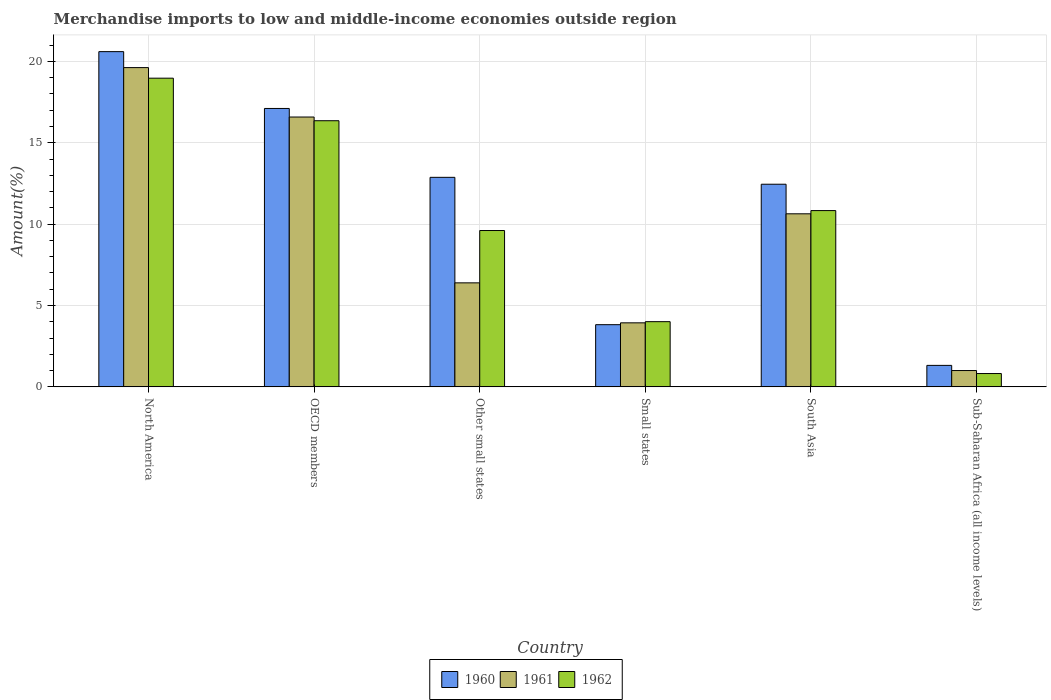How many different coloured bars are there?
Your answer should be very brief. 3. How many groups of bars are there?
Provide a short and direct response. 6. Are the number of bars on each tick of the X-axis equal?
Make the answer very short. Yes. How many bars are there on the 3rd tick from the left?
Make the answer very short. 3. How many bars are there on the 1st tick from the right?
Keep it short and to the point. 3. What is the label of the 3rd group of bars from the left?
Give a very brief answer. Other small states. What is the percentage of amount earned from merchandise imports in 1960 in OECD members?
Provide a succinct answer. 17.11. Across all countries, what is the maximum percentage of amount earned from merchandise imports in 1962?
Give a very brief answer. 18.97. Across all countries, what is the minimum percentage of amount earned from merchandise imports in 1962?
Make the answer very short. 0.82. In which country was the percentage of amount earned from merchandise imports in 1961 maximum?
Keep it short and to the point. North America. In which country was the percentage of amount earned from merchandise imports in 1961 minimum?
Offer a very short reply. Sub-Saharan Africa (all income levels). What is the total percentage of amount earned from merchandise imports in 1962 in the graph?
Make the answer very short. 60.58. What is the difference between the percentage of amount earned from merchandise imports in 1960 in North America and that in OECD members?
Provide a short and direct response. 3.49. What is the difference between the percentage of amount earned from merchandise imports in 1960 in North America and the percentage of amount earned from merchandise imports in 1962 in South Asia?
Provide a succinct answer. 9.77. What is the average percentage of amount earned from merchandise imports in 1962 per country?
Your answer should be compact. 10.1. What is the difference between the percentage of amount earned from merchandise imports of/in 1962 and percentage of amount earned from merchandise imports of/in 1960 in Sub-Saharan Africa (all income levels)?
Ensure brevity in your answer.  -0.5. In how many countries, is the percentage of amount earned from merchandise imports in 1962 greater than 12 %?
Provide a short and direct response. 2. What is the ratio of the percentage of amount earned from merchandise imports in 1961 in North America to that in Sub-Saharan Africa (all income levels)?
Provide a succinct answer. 19.54. Is the percentage of amount earned from merchandise imports in 1962 in Other small states less than that in Sub-Saharan Africa (all income levels)?
Ensure brevity in your answer.  No. What is the difference between the highest and the second highest percentage of amount earned from merchandise imports in 1962?
Your answer should be compact. -2.61. What is the difference between the highest and the lowest percentage of amount earned from merchandise imports in 1960?
Provide a short and direct response. 19.28. What does the 2nd bar from the left in Other small states represents?
Offer a very short reply. 1961. How many bars are there?
Offer a very short reply. 18. How many countries are there in the graph?
Your answer should be compact. 6. What is the difference between two consecutive major ticks on the Y-axis?
Provide a succinct answer. 5. Are the values on the major ticks of Y-axis written in scientific E-notation?
Give a very brief answer. No. Does the graph contain any zero values?
Offer a very short reply. No. Does the graph contain grids?
Your response must be concise. Yes. What is the title of the graph?
Give a very brief answer. Merchandise imports to low and middle-income economies outside region. Does "1983" appear as one of the legend labels in the graph?
Provide a short and direct response. No. What is the label or title of the Y-axis?
Keep it short and to the point. Amount(%). What is the Amount(%) of 1960 in North America?
Give a very brief answer. 20.6. What is the Amount(%) in 1961 in North America?
Offer a terse response. 19.62. What is the Amount(%) in 1962 in North America?
Ensure brevity in your answer.  18.97. What is the Amount(%) of 1960 in OECD members?
Your response must be concise. 17.11. What is the Amount(%) of 1961 in OECD members?
Your answer should be compact. 16.58. What is the Amount(%) in 1962 in OECD members?
Your answer should be compact. 16.35. What is the Amount(%) of 1960 in Other small states?
Keep it short and to the point. 12.87. What is the Amount(%) in 1961 in Other small states?
Provide a succinct answer. 6.39. What is the Amount(%) in 1962 in Other small states?
Provide a short and direct response. 9.61. What is the Amount(%) in 1960 in Small states?
Your response must be concise. 3.82. What is the Amount(%) in 1961 in Small states?
Provide a succinct answer. 3.93. What is the Amount(%) of 1962 in Small states?
Ensure brevity in your answer.  4.01. What is the Amount(%) in 1960 in South Asia?
Keep it short and to the point. 12.45. What is the Amount(%) of 1961 in South Asia?
Provide a succinct answer. 10.63. What is the Amount(%) of 1962 in South Asia?
Provide a succinct answer. 10.83. What is the Amount(%) of 1960 in Sub-Saharan Africa (all income levels)?
Your answer should be very brief. 1.32. What is the Amount(%) of 1961 in Sub-Saharan Africa (all income levels)?
Give a very brief answer. 1. What is the Amount(%) of 1962 in Sub-Saharan Africa (all income levels)?
Ensure brevity in your answer.  0.82. Across all countries, what is the maximum Amount(%) of 1960?
Ensure brevity in your answer.  20.6. Across all countries, what is the maximum Amount(%) in 1961?
Provide a short and direct response. 19.62. Across all countries, what is the maximum Amount(%) in 1962?
Your answer should be very brief. 18.97. Across all countries, what is the minimum Amount(%) of 1960?
Ensure brevity in your answer.  1.32. Across all countries, what is the minimum Amount(%) of 1961?
Make the answer very short. 1. Across all countries, what is the minimum Amount(%) of 1962?
Keep it short and to the point. 0.82. What is the total Amount(%) of 1960 in the graph?
Give a very brief answer. 68.17. What is the total Amount(%) in 1961 in the graph?
Provide a short and direct response. 58.16. What is the total Amount(%) of 1962 in the graph?
Your answer should be very brief. 60.58. What is the difference between the Amount(%) of 1960 in North America and that in OECD members?
Provide a short and direct response. 3.49. What is the difference between the Amount(%) of 1961 in North America and that in OECD members?
Make the answer very short. 3.04. What is the difference between the Amount(%) of 1962 in North America and that in OECD members?
Give a very brief answer. 2.61. What is the difference between the Amount(%) in 1960 in North America and that in Other small states?
Give a very brief answer. 7.72. What is the difference between the Amount(%) in 1961 in North America and that in Other small states?
Ensure brevity in your answer.  13.22. What is the difference between the Amount(%) in 1962 in North America and that in Other small states?
Ensure brevity in your answer.  9.36. What is the difference between the Amount(%) of 1960 in North America and that in Small states?
Your answer should be compact. 16.78. What is the difference between the Amount(%) of 1961 in North America and that in Small states?
Offer a terse response. 15.68. What is the difference between the Amount(%) in 1962 in North America and that in Small states?
Ensure brevity in your answer.  14.96. What is the difference between the Amount(%) of 1960 in North America and that in South Asia?
Ensure brevity in your answer.  8.15. What is the difference between the Amount(%) in 1961 in North America and that in South Asia?
Provide a succinct answer. 8.98. What is the difference between the Amount(%) in 1962 in North America and that in South Asia?
Your response must be concise. 8.13. What is the difference between the Amount(%) of 1960 in North America and that in Sub-Saharan Africa (all income levels)?
Keep it short and to the point. 19.28. What is the difference between the Amount(%) in 1961 in North America and that in Sub-Saharan Africa (all income levels)?
Provide a short and direct response. 18.61. What is the difference between the Amount(%) of 1962 in North America and that in Sub-Saharan Africa (all income levels)?
Provide a short and direct response. 18.15. What is the difference between the Amount(%) of 1960 in OECD members and that in Other small states?
Your answer should be very brief. 4.23. What is the difference between the Amount(%) of 1961 in OECD members and that in Other small states?
Give a very brief answer. 10.19. What is the difference between the Amount(%) of 1962 in OECD members and that in Other small states?
Provide a short and direct response. 6.75. What is the difference between the Amount(%) of 1960 in OECD members and that in Small states?
Ensure brevity in your answer.  13.28. What is the difference between the Amount(%) in 1961 in OECD members and that in Small states?
Offer a very short reply. 12.65. What is the difference between the Amount(%) of 1962 in OECD members and that in Small states?
Your answer should be compact. 12.35. What is the difference between the Amount(%) of 1960 in OECD members and that in South Asia?
Keep it short and to the point. 4.66. What is the difference between the Amount(%) in 1961 in OECD members and that in South Asia?
Offer a very short reply. 5.95. What is the difference between the Amount(%) of 1962 in OECD members and that in South Asia?
Your response must be concise. 5.52. What is the difference between the Amount(%) of 1960 in OECD members and that in Sub-Saharan Africa (all income levels)?
Keep it short and to the point. 15.79. What is the difference between the Amount(%) of 1961 in OECD members and that in Sub-Saharan Africa (all income levels)?
Provide a short and direct response. 15.58. What is the difference between the Amount(%) in 1962 in OECD members and that in Sub-Saharan Africa (all income levels)?
Give a very brief answer. 15.53. What is the difference between the Amount(%) of 1960 in Other small states and that in Small states?
Ensure brevity in your answer.  9.05. What is the difference between the Amount(%) in 1961 in Other small states and that in Small states?
Give a very brief answer. 2.46. What is the difference between the Amount(%) of 1962 in Other small states and that in Small states?
Provide a short and direct response. 5.6. What is the difference between the Amount(%) of 1960 in Other small states and that in South Asia?
Keep it short and to the point. 0.42. What is the difference between the Amount(%) in 1961 in Other small states and that in South Asia?
Your answer should be very brief. -4.24. What is the difference between the Amount(%) in 1962 in Other small states and that in South Asia?
Ensure brevity in your answer.  -1.23. What is the difference between the Amount(%) in 1960 in Other small states and that in Sub-Saharan Africa (all income levels)?
Keep it short and to the point. 11.55. What is the difference between the Amount(%) of 1961 in Other small states and that in Sub-Saharan Africa (all income levels)?
Provide a short and direct response. 5.39. What is the difference between the Amount(%) in 1962 in Other small states and that in Sub-Saharan Africa (all income levels)?
Your answer should be compact. 8.79. What is the difference between the Amount(%) in 1960 in Small states and that in South Asia?
Give a very brief answer. -8.63. What is the difference between the Amount(%) of 1961 in Small states and that in South Asia?
Provide a short and direct response. -6.7. What is the difference between the Amount(%) of 1962 in Small states and that in South Asia?
Ensure brevity in your answer.  -6.83. What is the difference between the Amount(%) in 1960 in Small states and that in Sub-Saharan Africa (all income levels)?
Ensure brevity in your answer.  2.5. What is the difference between the Amount(%) of 1961 in Small states and that in Sub-Saharan Africa (all income levels)?
Provide a short and direct response. 2.93. What is the difference between the Amount(%) in 1962 in Small states and that in Sub-Saharan Africa (all income levels)?
Your answer should be compact. 3.19. What is the difference between the Amount(%) of 1960 in South Asia and that in Sub-Saharan Africa (all income levels)?
Offer a very short reply. 11.13. What is the difference between the Amount(%) in 1961 in South Asia and that in Sub-Saharan Africa (all income levels)?
Your answer should be very brief. 9.63. What is the difference between the Amount(%) of 1962 in South Asia and that in Sub-Saharan Africa (all income levels)?
Give a very brief answer. 10.01. What is the difference between the Amount(%) in 1960 in North America and the Amount(%) in 1961 in OECD members?
Give a very brief answer. 4.02. What is the difference between the Amount(%) in 1960 in North America and the Amount(%) in 1962 in OECD members?
Offer a terse response. 4.24. What is the difference between the Amount(%) in 1961 in North America and the Amount(%) in 1962 in OECD members?
Offer a terse response. 3.26. What is the difference between the Amount(%) of 1960 in North America and the Amount(%) of 1961 in Other small states?
Your answer should be very brief. 14.21. What is the difference between the Amount(%) in 1960 in North America and the Amount(%) in 1962 in Other small states?
Give a very brief answer. 10.99. What is the difference between the Amount(%) in 1961 in North America and the Amount(%) in 1962 in Other small states?
Your answer should be very brief. 10.01. What is the difference between the Amount(%) in 1960 in North America and the Amount(%) in 1961 in Small states?
Your response must be concise. 16.66. What is the difference between the Amount(%) of 1960 in North America and the Amount(%) of 1962 in Small states?
Provide a short and direct response. 16.59. What is the difference between the Amount(%) of 1961 in North America and the Amount(%) of 1962 in Small states?
Offer a terse response. 15.61. What is the difference between the Amount(%) of 1960 in North America and the Amount(%) of 1961 in South Asia?
Make the answer very short. 9.96. What is the difference between the Amount(%) in 1960 in North America and the Amount(%) in 1962 in South Asia?
Provide a short and direct response. 9.77. What is the difference between the Amount(%) of 1961 in North America and the Amount(%) of 1962 in South Asia?
Keep it short and to the point. 8.78. What is the difference between the Amount(%) in 1960 in North America and the Amount(%) in 1961 in Sub-Saharan Africa (all income levels)?
Give a very brief answer. 19.59. What is the difference between the Amount(%) of 1960 in North America and the Amount(%) of 1962 in Sub-Saharan Africa (all income levels)?
Provide a short and direct response. 19.78. What is the difference between the Amount(%) of 1961 in North America and the Amount(%) of 1962 in Sub-Saharan Africa (all income levels)?
Your answer should be very brief. 18.8. What is the difference between the Amount(%) of 1960 in OECD members and the Amount(%) of 1961 in Other small states?
Make the answer very short. 10.71. What is the difference between the Amount(%) in 1960 in OECD members and the Amount(%) in 1962 in Other small states?
Provide a succinct answer. 7.5. What is the difference between the Amount(%) of 1961 in OECD members and the Amount(%) of 1962 in Other small states?
Give a very brief answer. 6.97. What is the difference between the Amount(%) in 1960 in OECD members and the Amount(%) in 1961 in Small states?
Your response must be concise. 13.17. What is the difference between the Amount(%) of 1960 in OECD members and the Amount(%) of 1962 in Small states?
Give a very brief answer. 13.1. What is the difference between the Amount(%) in 1961 in OECD members and the Amount(%) in 1962 in Small states?
Offer a very short reply. 12.57. What is the difference between the Amount(%) in 1960 in OECD members and the Amount(%) in 1961 in South Asia?
Offer a terse response. 6.47. What is the difference between the Amount(%) in 1960 in OECD members and the Amount(%) in 1962 in South Asia?
Offer a terse response. 6.27. What is the difference between the Amount(%) of 1961 in OECD members and the Amount(%) of 1962 in South Asia?
Provide a short and direct response. 5.75. What is the difference between the Amount(%) of 1960 in OECD members and the Amount(%) of 1961 in Sub-Saharan Africa (all income levels)?
Your answer should be very brief. 16.1. What is the difference between the Amount(%) of 1960 in OECD members and the Amount(%) of 1962 in Sub-Saharan Africa (all income levels)?
Offer a very short reply. 16.29. What is the difference between the Amount(%) of 1961 in OECD members and the Amount(%) of 1962 in Sub-Saharan Africa (all income levels)?
Your answer should be very brief. 15.76. What is the difference between the Amount(%) of 1960 in Other small states and the Amount(%) of 1961 in Small states?
Give a very brief answer. 8.94. What is the difference between the Amount(%) in 1960 in Other small states and the Amount(%) in 1962 in Small states?
Your answer should be very brief. 8.87. What is the difference between the Amount(%) in 1961 in Other small states and the Amount(%) in 1962 in Small states?
Give a very brief answer. 2.39. What is the difference between the Amount(%) of 1960 in Other small states and the Amount(%) of 1961 in South Asia?
Give a very brief answer. 2.24. What is the difference between the Amount(%) of 1960 in Other small states and the Amount(%) of 1962 in South Asia?
Give a very brief answer. 2.04. What is the difference between the Amount(%) of 1961 in Other small states and the Amount(%) of 1962 in South Asia?
Ensure brevity in your answer.  -4.44. What is the difference between the Amount(%) in 1960 in Other small states and the Amount(%) in 1961 in Sub-Saharan Africa (all income levels)?
Provide a short and direct response. 11.87. What is the difference between the Amount(%) in 1960 in Other small states and the Amount(%) in 1962 in Sub-Saharan Africa (all income levels)?
Your answer should be compact. 12.06. What is the difference between the Amount(%) of 1961 in Other small states and the Amount(%) of 1962 in Sub-Saharan Africa (all income levels)?
Your response must be concise. 5.57. What is the difference between the Amount(%) of 1960 in Small states and the Amount(%) of 1961 in South Asia?
Your answer should be very brief. -6.81. What is the difference between the Amount(%) in 1960 in Small states and the Amount(%) in 1962 in South Asia?
Ensure brevity in your answer.  -7.01. What is the difference between the Amount(%) in 1961 in Small states and the Amount(%) in 1962 in South Asia?
Your answer should be very brief. -6.9. What is the difference between the Amount(%) of 1960 in Small states and the Amount(%) of 1961 in Sub-Saharan Africa (all income levels)?
Ensure brevity in your answer.  2.82. What is the difference between the Amount(%) in 1960 in Small states and the Amount(%) in 1962 in Sub-Saharan Africa (all income levels)?
Offer a terse response. 3. What is the difference between the Amount(%) in 1961 in Small states and the Amount(%) in 1962 in Sub-Saharan Africa (all income levels)?
Offer a very short reply. 3.12. What is the difference between the Amount(%) in 1960 in South Asia and the Amount(%) in 1961 in Sub-Saharan Africa (all income levels)?
Provide a succinct answer. 11.45. What is the difference between the Amount(%) of 1960 in South Asia and the Amount(%) of 1962 in Sub-Saharan Africa (all income levels)?
Your answer should be compact. 11.63. What is the difference between the Amount(%) of 1961 in South Asia and the Amount(%) of 1962 in Sub-Saharan Africa (all income levels)?
Provide a succinct answer. 9.81. What is the average Amount(%) in 1960 per country?
Your answer should be very brief. 11.36. What is the average Amount(%) of 1961 per country?
Make the answer very short. 9.69. What is the average Amount(%) in 1962 per country?
Keep it short and to the point. 10.1. What is the difference between the Amount(%) of 1960 and Amount(%) of 1961 in North America?
Offer a very short reply. 0.98. What is the difference between the Amount(%) of 1960 and Amount(%) of 1962 in North America?
Offer a very short reply. 1.63. What is the difference between the Amount(%) of 1961 and Amount(%) of 1962 in North America?
Your answer should be compact. 0.65. What is the difference between the Amount(%) of 1960 and Amount(%) of 1961 in OECD members?
Make the answer very short. 0.53. What is the difference between the Amount(%) of 1960 and Amount(%) of 1962 in OECD members?
Keep it short and to the point. 0.75. What is the difference between the Amount(%) of 1961 and Amount(%) of 1962 in OECD members?
Your answer should be compact. 0.23. What is the difference between the Amount(%) in 1960 and Amount(%) in 1961 in Other small states?
Provide a short and direct response. 6.48. What is the difference between the Amount(%) of 1960 and Amount(%) of 1962 in Other small states?
Your response must be concise. 3.27. What is the difference between the Amount(%) of 1961 and Amount(%) of 1962 in Other small states?
Provide a succinct answer. -3.21. What is the difference between the Amount(%) in 1960 and Amount(%) in 1961 in Small states?
Offer a very short reply. -0.11. What is the difference between the Amount(%) of 1960 and Amount(%) of 1962 in Small states?
Your answer should be compact. -0.19. What is the difference between the Amount(%) in 1961 and Amount(%) in 1962 in Small states?
Keep it short and to the point. -0.07. What is the difference between the Amount(%) of 1960 and Amount(%) of 1961 in South Asia?
Provide a short and direct response. 1.82. What is the difference between the Amount(%) in 1960 and Amount(%) in 1962 in South Asia?
Provide a short and direct response. 1.62. What is the difference between the Amount(%) in 1961 and Amount(%) in 1962 in South Asia?
Ensure brevity in your answer.  -0.2. What is the difference between the Amount(%) in 1960 and Amount(%) in 1961 in Sub-Saharan Africa (all income levels)?
Your answer should be compact. 0.32. What is the difference between the Amount(%) of 1960 and Amount(%) of 1962 in Sub-Saharan Africa (all income levels)?
Offer a terse response. 0.5. What is the difference between the Amount(%) of 1961 and Amount(%) of 1962 in Sub-Saharan Africa (all income levels)?
Offer a terse response. 0.18. What is the ratio of the Amount(%) in 1960 in North America to that in OECD members?
Give a very brief answer. 1.2. What is the ratio of the Amount(%) of 1961 in North America to that in OECD members?
Make the answer very short. 1.18. What is the ratio of the Amount(%) in 1962 in North America to that in OECD members?
Make the answer very short. 1.16. What is the ratio of the Amount(%) of 1960 in North America to that in Other small states?
Offer a very short reply. 1.6. What is the ratio of the Amount(%) in 1961 in North America to that in Other small states?
Offer a very short reply. 3.07. What is the ratio of the Amount(%) of 1962 in North America to that in Other small states?
Make the answer very short. 1.97. What is the ratio of the Amount(%) of 1960 in North America to that in Small states?
Your answer should be compact. 5.39. What is the ratio of the Amount(%) of 1961 in North America to that in Small states?
Your answer should be very brief. 4.99. What is the ratio of the Amount(%) in 1962 in North America to that in Small states?
Provide a succinct answer. 4.73. What is the ratio of the Amount(%) in 1960 in North America to that in South Asia?
Your answer should be very brief. 1.65. What is the ratio of the Amount(%) in 1961 in North America to that in South Asia?
Offer a terse response. 1.84. What is the ratio of the Amount(%) in 1962 in North America to that in South Asia?
Keep it short and to the point. 1.75. What is the ratio of the Amount(%) of 1960 in North America to that in Sub-Saharan Africa (all income levels)?
Provide a succinct answer. 15.6. What is the ratio of the Amount(%) of 1961 in North America to that in Sub-Saharan Africa (all income levels)?
Your response must be concise. 19.55. What is the ratio of the Amount(%) in 1962 in North America to that in Sub-Saharan Africa (all income levels)?
Offer a terse response. 23.16. What is the ratio of the Amount(%) in 1960 in OECD members to that in Other small states?
Keep it short and to the point. 1.33. What is the ratio of the Amount(%) in 1961 in OECD members to that in Other small states?
Offer a very short reply. 2.59. What is the ratio of the Amount(%) in 1962 in OECD members to that in Other small states?
Keep it short and to the point. 1.7. What is the ratio of the Amount(%) in 1960 in OECD members to that in Small states?
Your response must be concise. 4.48. What is the ratio of the Amount(%) in 1961 in OECD members to that in Small states?
Ensure brevity in your answer.  4.21. What is the ratio of the Amount(%) in 1962 in OECD members to that in Small states?
Offer a very short reply. 4.08. What is the ratio of the Amount(%) in 1960 in OECD members to that in South Asia?
Your answer should be compact. 1.37. What is the ratio of the Amount(%) in 1961 in OECD members to that in South Asia?
Give a very brief answer. 1.56. What is the ratio of the Amount(%) of 1962 in OECD members to that in South Asia?
Provide a succinct answer. 1.51. What is the ratio of the Amount(%) of 1960 in OECD members to that in Sub-Saharan Africa (all income levels)?
Offer a very short reply. 12.95. What is the ratio of the Amount(%) of 1961 in OECD members to that in Sub-Saharan Africa (all income levels)?
Your response must be concise. 16.52. What is the ratio of the Amount(%) of 1962 in OECD members to that in Sub-Saharan Africa (all income levels)?
Give a very brief answer. 19.97. What is the ratio of the Amount(%) of 1960 in Other small states to that in Small states?
Make the answer very short. 3.37. What is the ratio of the Amount(%) in 1961 in Other small states to that in Small states?
Your answer should be compact. 1.62. What is the ratio of the Amount(%) in 1962 in Other small states to that in Small states?
Offer a very short reply. 2.4. What is the ratio of the Amount(%) in 1960 in Other small states to that in South Asia?
Your response must be concise. 1.03. What is the ratio of the Amount(%) of 1961 in Other small states to that in South Asia?
Provide a short and direct response. 0.6. What is the ratio of the Amount(%) of 1962 in Other small states to that in South Asia?
Provide a succinct answer. 0.89. What is the ratio of the Amount(%) of 1960 in Other small states to that in Sub-Saharan Africa (all income levels)?
Provide a succinct answer. 9.75. What is the ratio of the Amount(%) of 1961 in Other small states to that in Sub-Saharan Africa (all income levels)?
Your answer should be very brief. 6.37. What is the ratio of the Amount(%) in 1962 in Other small states to that in Sub-Saharan Africa (all income levels)?
Your answer should be very brief. 11.73. What is the ratio of the Amount(%) in 1960 in Small states to that in South Asia?
Offer a very short reply. 0.31. What is the ratio of the Amount(%) of 1961 in Small states to that in South Asia?
Give a very brief answer. 0.37. What is the ratio of the Amount(%) in 1962 in Small states to that in South Asia?
Offer a terse response. 0.37. What is the ratio of the Amount(%) of 1960 in Small states to that in Sub-Saharan Africa (all income levels)?
Make the answer very short. 2.89. What is the ratio of the Amount(%) of 1961 in Small states to that in Sub-Saharan Africa (all income levels)?
Provide a short and direct response. 3.92. What is the ratio of the Amount(%) of 1962 in Small states to that in Sub-Saharan Africa (all income levels)?
Offer a terse response. 4.89. What is the ratio of the Amount(%) of 1960 in South Asia to that in Sub-Saharan Africa (all income levels)?
Your answer should be compact. 9.43. What is the ratio of the Amount(%) of 1961 in South Asia to that in Sub-Saharan Africa (all income levels)?
Provide a short and direct response. 10.59. What is the ratio of the Amount(%) in 1962 in South Asia to that in Sub-Saharan Africa (all income levels)?
Make the answer very short. 13.23. What is the difference between the highest and the second highest Amount(%) of 1960?
Your response must be concise. 3.49. What is the difference between the highest and the second highest Amount(%) in 1961?
Your answer should be compact. 3.04. What is the difference between the highest and the second highest Amount(%) in 1962?
Make the answer very short. 2.61. What is the difference between the highest and the lowest Amount(%) of 1960?
Your answer should be very brief. 19.28. What is the difference between the highest and the lowest Amount(%) in 1961?
Your answer should be very brief. 18.61. What is the difference between the highest and the lowest Amount(%) of 1962?
Ensure brevity in your answer.  18.15. 